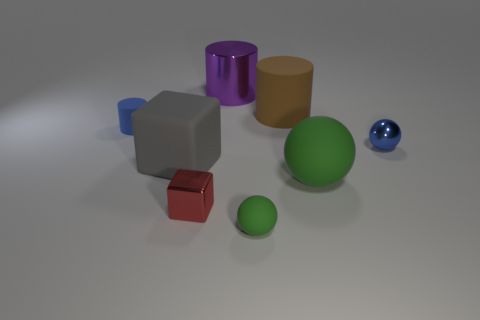What number of small rubber balls have the same color as the big matte sphere?
Provide a short and direct response. 1. How many brown rubber cylinders are in front of the tiny sphere that is left of the tiny shiny thing that is behind the big gray rubber block?
Your answer should be compact. 0. Does the large sphere have the same color as the tiny matte sphere?
Offer a terse response. Yes. What number of matte cylinders are on the left side of the large metal cylinder and to the right of the tiny rubber sphere?
Offer a terse response. 0. What is the shape of the blue object to the right of the small red shiny object?
Provide a succinct answer. Sphere. Are there fewer red things to the right of the big purple shiny cylinder than big matte things that are in front of the blue rubber cylinder?
Provide a short and direct response. Yes. Is the material of the cylinder that is to the left of the large purple shiny cylinder the same as the block that is on the right side of the gray thing?
Provide a short and direct response. No. The tiny blue metal thing has what shape?
Offer a very short reply. Sphere. Is the number of blue objects that are right of the purple cylinder greater than the number of brown objects that are to the left of the small red object?
Keep it short and to the point. Yes. Does the tiny green object that is on the right side of the red object have the same shape as the large matte thing in front of the gray object?
Offer a terse response. Yes. 